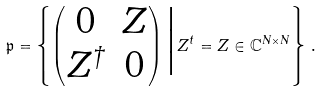Convert formula to latex. <formula><loc_0><loc_0><loc_500><loc_500>\mathfrak { p } = \left \{ \begin{pmatrix} 0 & Z \\ Z ^ { \dagger } & 0 \end{pmatrix} \Big | Z ^ { t } = Z \in \mathbb { C } ^ { N \times N } \right \} \, .</formula> 